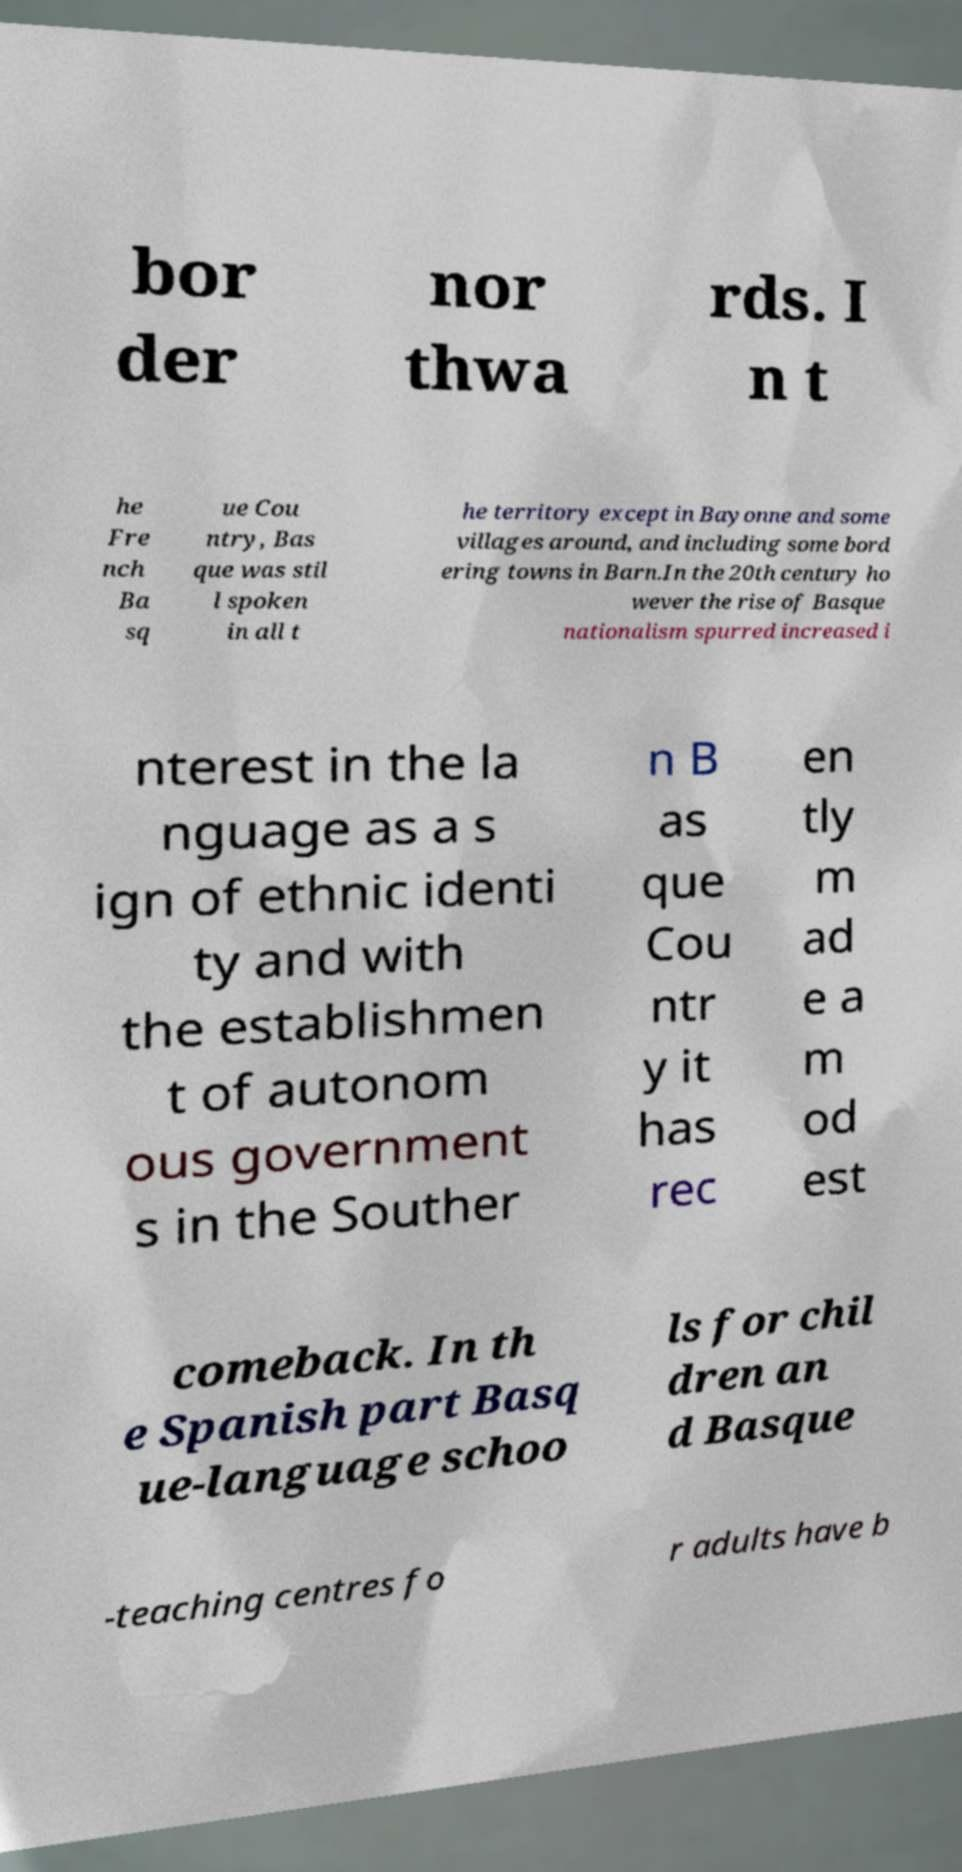What messages or text are displayed in this image? I need them in a readable, typed format. bor der nor thwa rds. I n t he Fre nch Ba sq ue Cou ntry, Bas que was stil l spoken in all t he territory except in Bayonne and some villages around, and including some bord ering towns in Barn.In the 20th century ho wever the rise of Basque nationalism spurred increased i nterest in the la nguage as a s ign of ethnic identi ty and with the establishmen t of autonom ous government s in the Souther n B as que Cou ntr y it has rec en tly m ad e a m od est comeback. In th e Spanish part Basq ue-language schoo ls for chil dren an d Basque -teaching centres fo r adults have b 